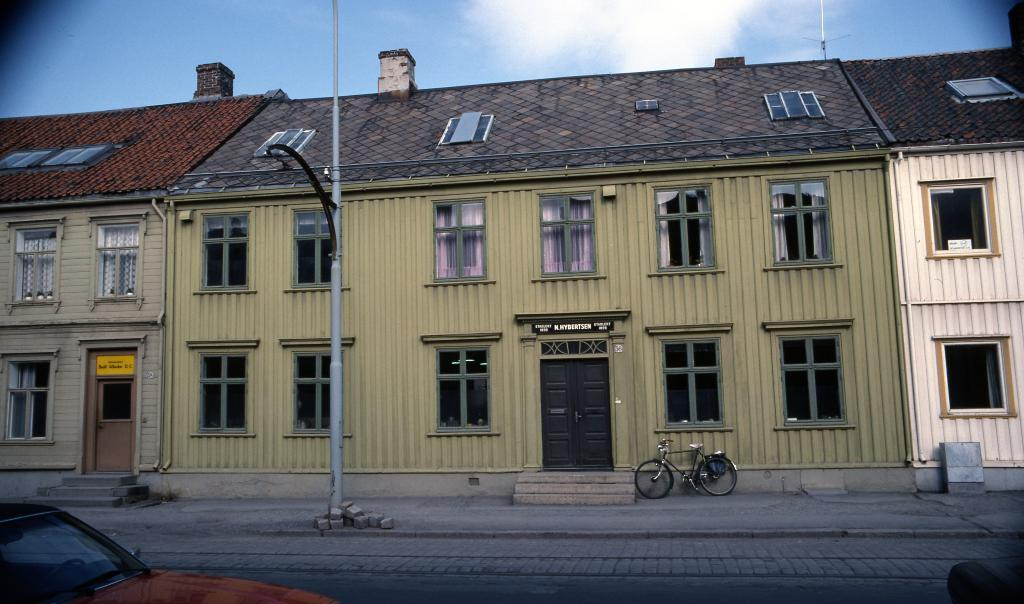What is the main subject of the image? There is a vehicle in the image. What is the setting of the image? There is a road, a path, and buildings in the image. Can you describe any other objects in the image? There is a pole and boards in the image. What can be seen in the background of the image? The sky is visible in the background of the image. What shape is the cork used to seal the bottle in the image? There is no bottle or cork present in the image. How many sides does the square table have in the image? There is no table, square or otherwise, present in the image. 